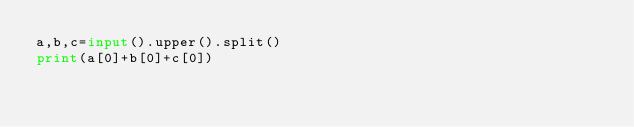<code> <loc_0><loc_0><loc_500><loc_500><_Python_>a,b,c=input().upper().split()
print(a[0]+b[0]+c[0])</code> 